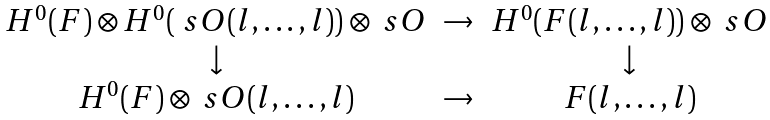<formula> <loc_0><loc_0><loc_500><loc_500>\begin{matrix} H ^ { 0 } ( F ) \otimes H ^ { 0 } ( \ s O ( l , \dots , l ) ) \otimes \ s O & \to & H ^ { 0 } ( F ( l , \dots , l ) ) \otimes \ s O \\ \downarrow & & \downarrow \\ H ^ { 0 } ( F ) \otimes \ s O ( l , \dots , l ) & \to & F ( l , \dots , l ) \end{matrix}</formula> 